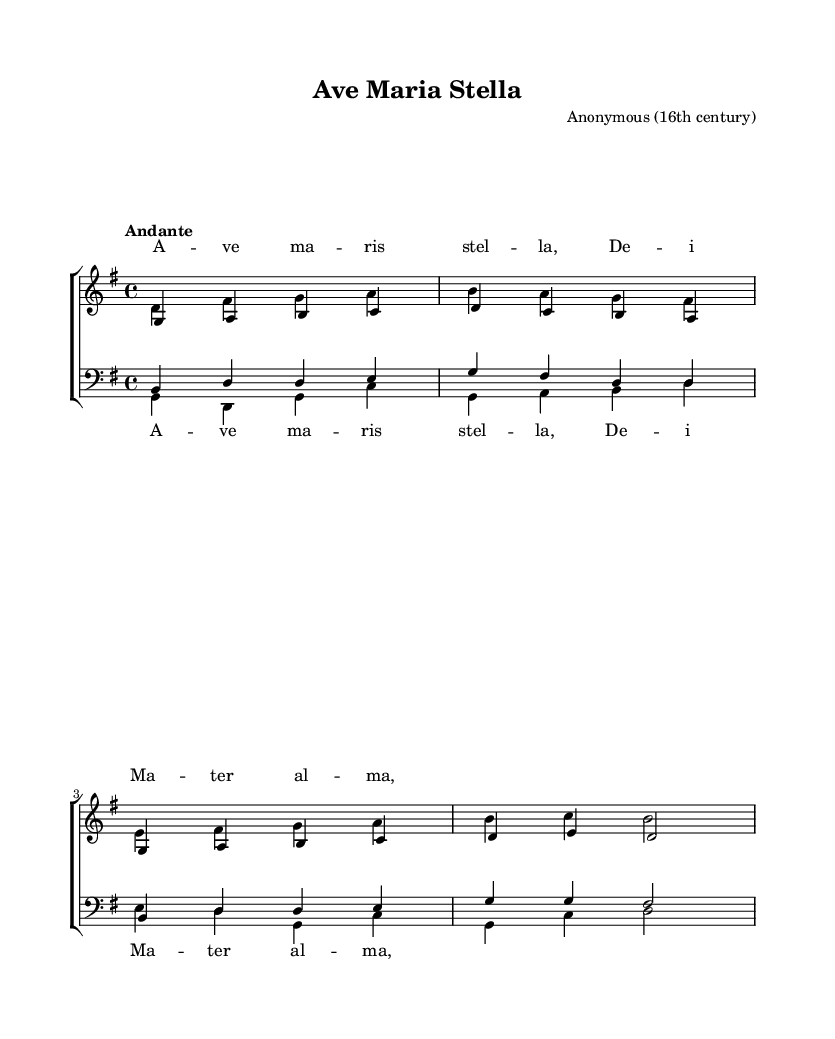What is the key signature of this music? The key signature is G major, which has one sharp (F#). This can be determined by looking at the sharp sign in the key signature at the beginning of the staff.
Answer: G major What is the time signature of the piece? The time signature is 4/4, indicated by the "4" over another "4" at the beginning of the piece; this shows there are four beats in each measure and a quarter note gets one beat.
Answer: 4/4 What is the tempo marking indicated for this piece? The tempo marking is "Andante," which suggests a moderately slow tempo. It is noted at the beginning above the staff.
Answer: Andante Which voice part starts with the note "G"? The soprano voice part starts with the note "G," as the very first note in the soprano line is G4.
Answer: Soprano How many measures are in the soprano music? There are four measures in the soprano music; this can be counted by identifying the vertical bar lines that separate each measure in the staff.
Answer: Four Which vocal parts are written in the treble clef? The soprano and alto parts are written in the treble clef, as indicated by the clef symbol at the start of these voice staffs, which typically signifies higher female ranges.
Answer: Soprano and Alto What is the last note of the bass music? The last note of the bass music is D, as indicated by the last note present in the bass part, which is marked D2.
Answer: D 